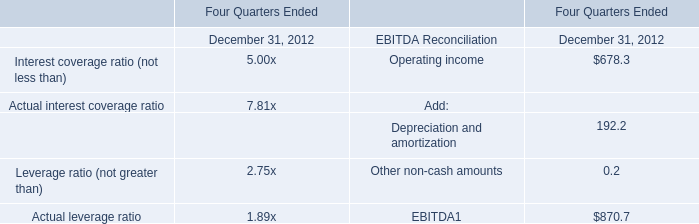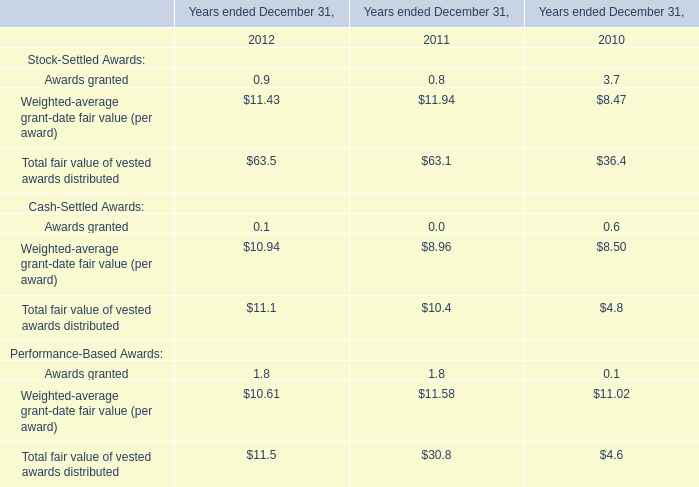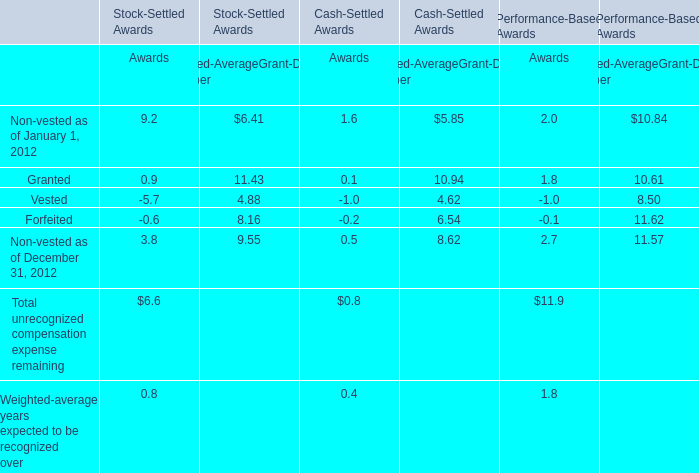What is the 50% of the Awards value of Total unrecognized compensation expense remaining for Stock-Settled Awards? 
Computations: (0.5 * 6.6)
Answer: 3.3. 